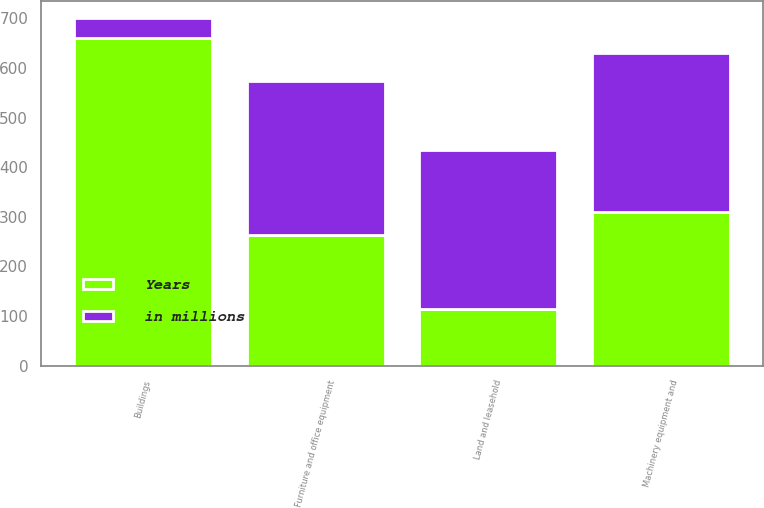Convert chart. <chart><loc_0><loc_0><loc_500><loc_500><stacked_bar_chart><ecel><fcel>Land and leasehold<fcel>Buildings<fcel>Machinery equipment and<fcel>Furniture and office equipment<nl><fcel>in millions<fcel>320<fcel>40<fcel>320<fcel>310<nl><fcel>Years<fcel>115<fcel>660<fcel>310<fcel>263<nl></chart> 